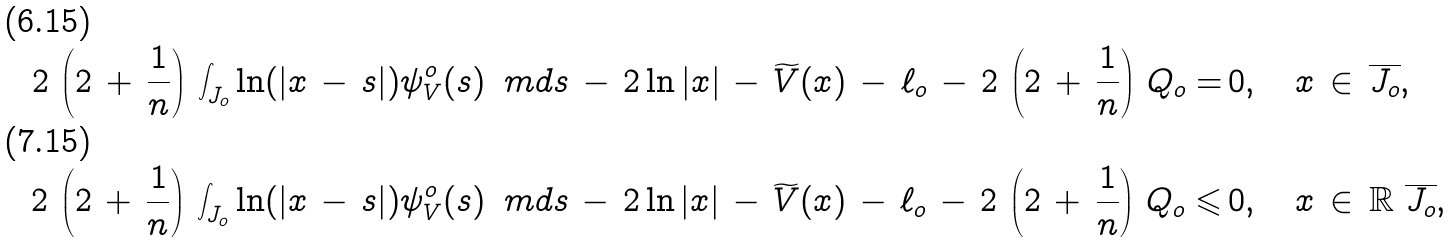Convert formula to latex. <formula><loc_0><loc_0><loc_500><loc_500>2 \, \left ( 2 \, + \, \frac { 1 } { n } \right ) \, \int _ { J _ { o } } \ln ( | x \, - \, s | ) \psi _ { V } ^ { o } ( s ) \, \ m d s \, - \, 2 \ln | x | \, - \, \widetilde { V } ( x ) \, - \, \ell _ { o } \, - \, 2 \, \left ( 2 \, + \, \frac { 1 } { n } \right ) \, Q _ { o } = & \, 0 , \quad x \, \in \, \overline { J _ { o } } , \\ 2 \, \left ( 2 \, + \, \frac { 1 } { n } \right ) \, \int _ { J _ { o } } \ln ( | x \, - \, s | ) \psi _ { V } ^ { o } ( s ) \, \ m d s \, - \, 2 \ln | x | \, - \, \widetilde { V } ( x ) \, - \, \ell _ { o } \, - \, 2 \, \left ( 2 \, + \, \frac { 1 } { n } \right ) \, Q _ { o } \leqslant & \, 0 , \quad x \, \in \, \mathbb { R } \ \overline { J _ { o } } ,</formula> 